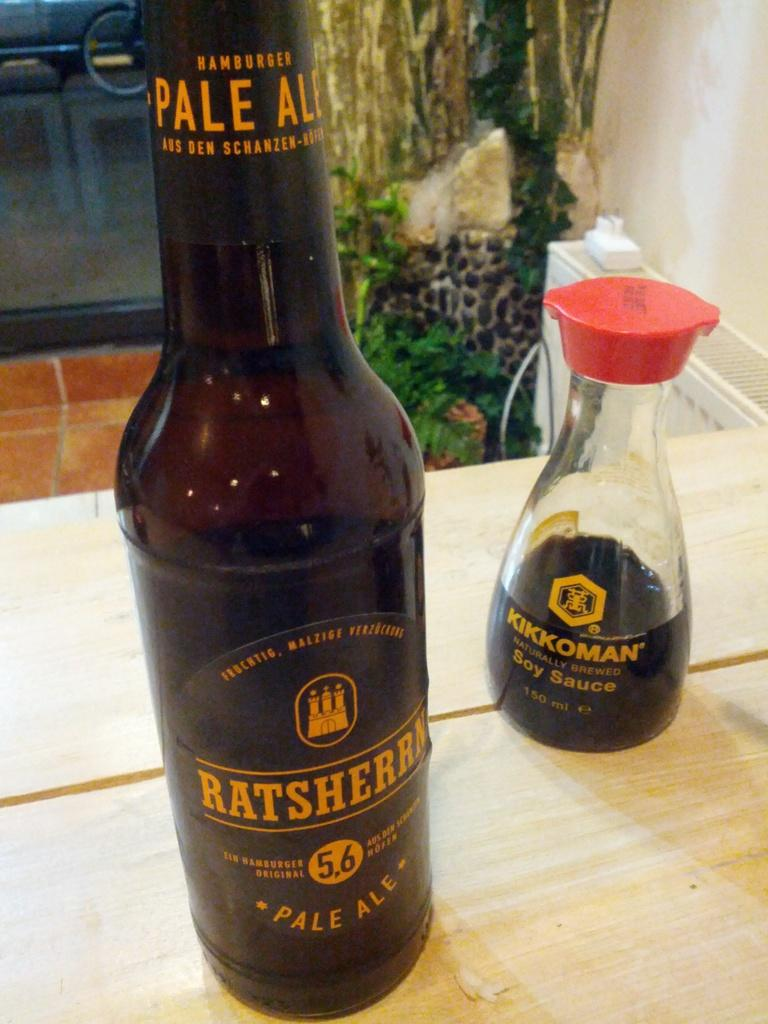<image>
Create a compact narrative representing the image presented. A bottle of Ratsherrn Pale Ale next to a bottle of Kikkoman Soy Sauce. 